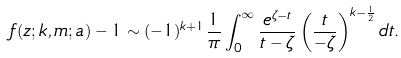<formula> <loc_0><loc_0><loc_500><loc_500>f ( z ; k , m ; a ) - 1 \sim ( - 1 ) ^ { k + 1 } \frac { 1 } { \pi } \int _ { 0 } ^ { \infty } \frac { e ^ { \zeta - t } } { t - \zeta } \left ( \frac { t } { - \zeta } \right ) ^ { k - \frac { 1 } { 2 } } d t .</formula> 